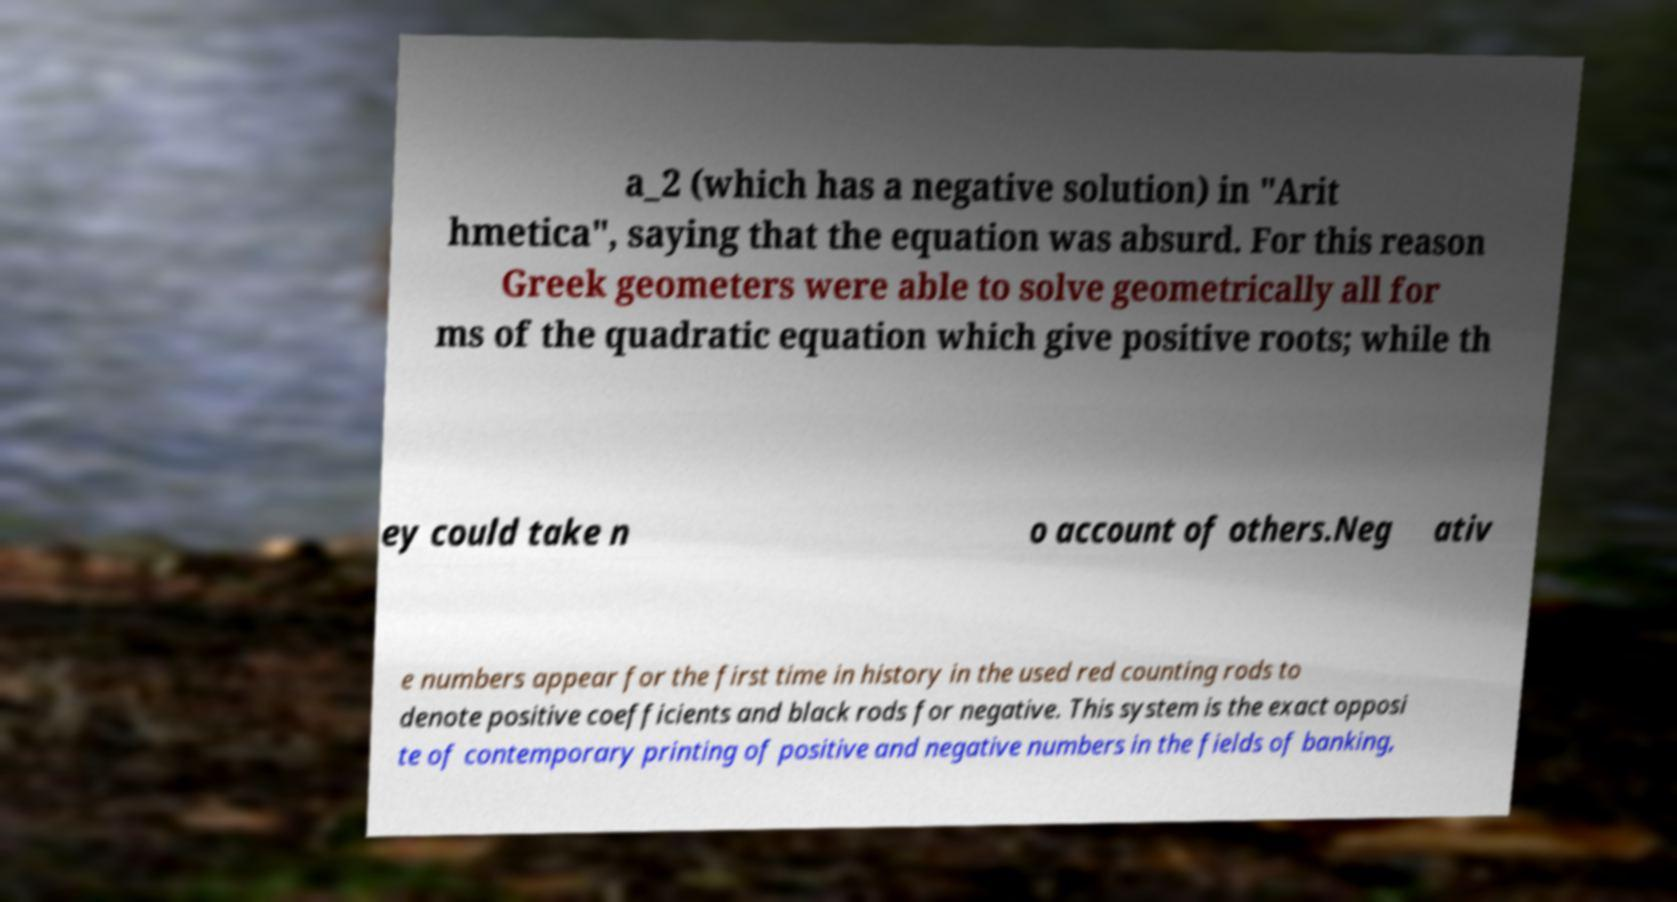What messages or text are displayed in this image? I need them in a readable, typed format. a_2 (which has a negative solution) in "Arit hmetica", saying that the equation was absurd. For this reason Greek geometers were able to solve geometrically all for ms of the quadratic equation which give positive roots; while th ey could take n o account of others.Neg ativ e numbers appear for the first time in history in the used red counting rods to denote positive coefficients and black rods for negative. This system is the exact opposi te of contemporary printing of positive and negative numbers in the fields of banking, 